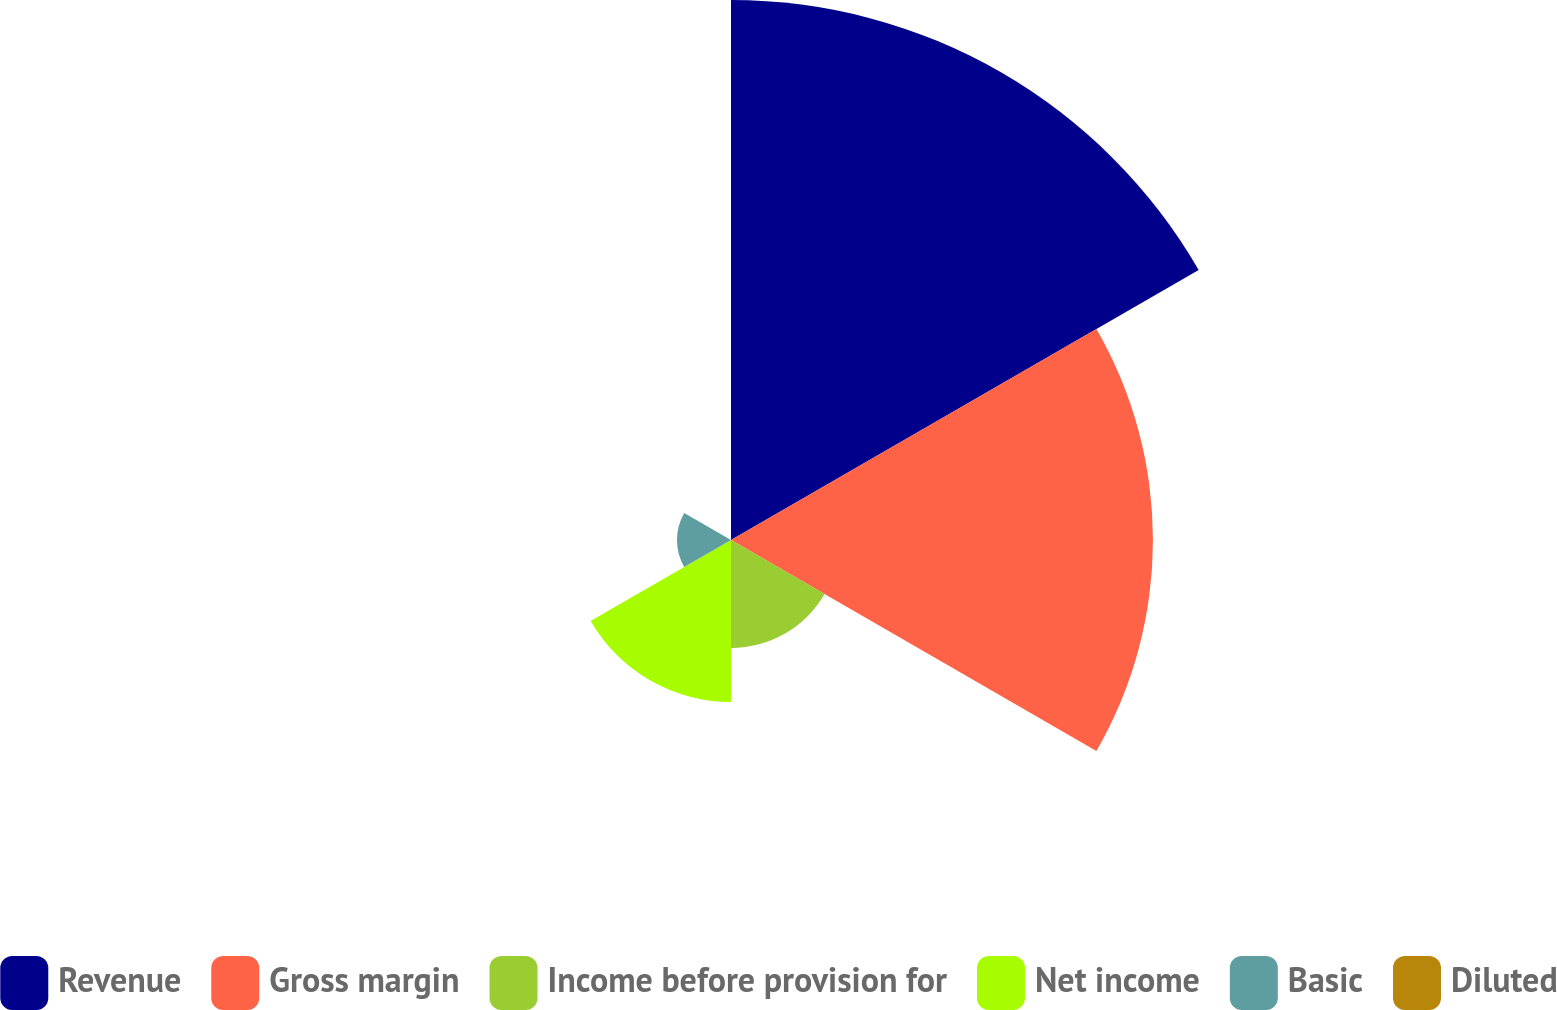<chart> <loc_0><loc_0><loc_500><loc_500><pie_chart><fcel>Revenue<fcel>Gross margin<fcel>Income before provision for<fcel>Net income<fcel>Basic<fcel>Diluted<nl><fcel>41.99%<fcel>32.81%<fcel>8.4%<fcel>12.6%<fcel>4.2%<fcel>0.0%<nl></chart> 